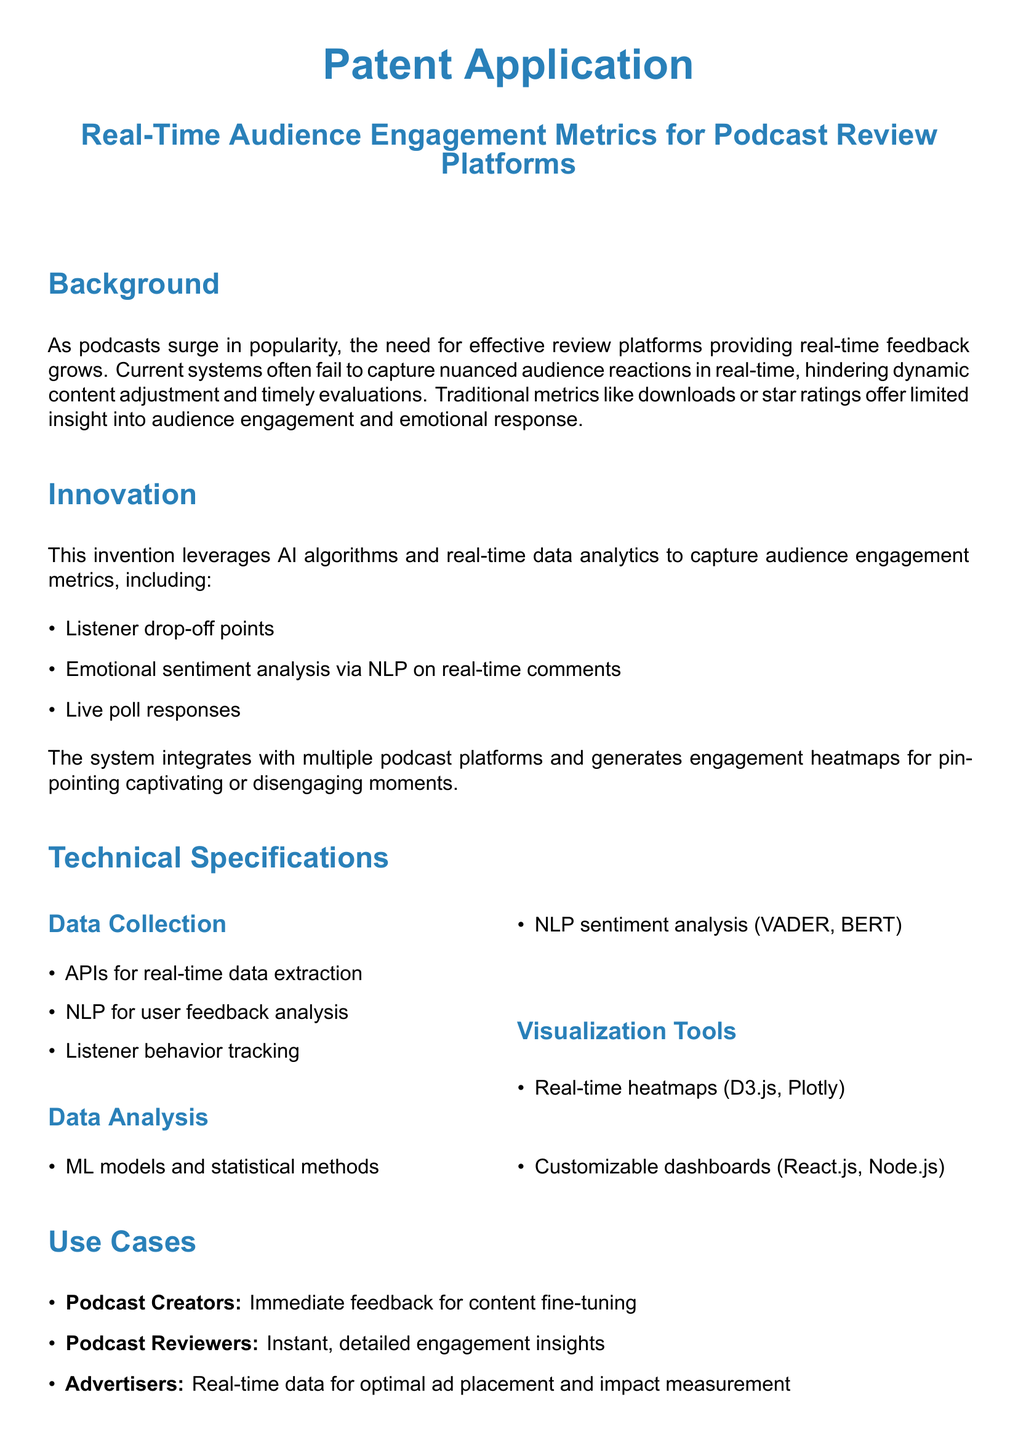What is the main focus of the patent application? The main focus of the patent application is on improving real-time audience engagement metrics for podcast review platforms.
Answer: Real-Time Audience Engagement Metrics for Podcast Review Platforms What problem does the invention aim to solve? The invention aims to solve the issue of traditional systems failing to capture nuanced audience reactions in real-time.
Answer: Audience reactions in real-time What are some of the audience engagement metrics mentioned? The mentioned engagement metrics include listener drop-off points, emotional sentiment analysis, and live poll responses.
Answer: Listener drop-off points, emotional sentiment analysis, live poll responses Which technologies are used for data visualization? The technologies used for data visualization include D3.js and Plotly.
Answer: D3.js, Plotly Who benefits from this real-time audience engagement metric system? The beneficiaries include podcast creators, podcast reviewers, and advertisers.
Answer: Podcast creators, podcast reviewers, advertisers What does NLP stand for in the context of this patent application? In this context, NLP stands for Natural Language Processing.
Answer: Natural Language Processing What is one application of the system for podcast creators? One application for podcast creators is immediate feedback for content fine-tuning.
Answer: Immediate feedback for content fine-tuning What is mentioned as a limitation of current podcast review systems? A limitation mentioned is that current systems offer limited insight into audience engagement and emotional response.
Answer: Limited insight into audience engagement and emotional response 